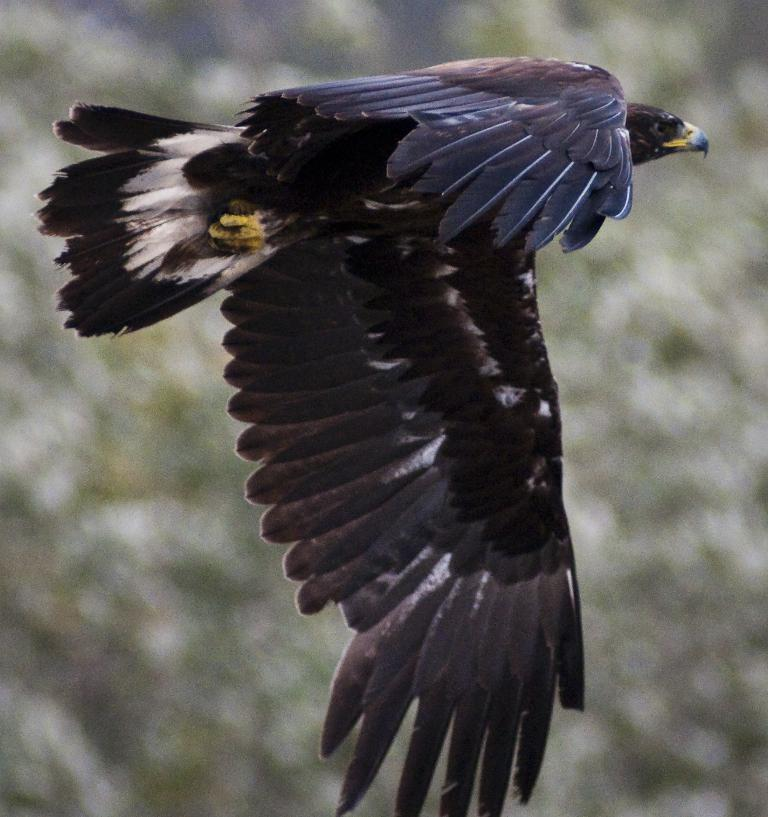What is the main subject of the image? The main subject of the image is a bird flying in the air. Can you describe the background of the image? The background of the image is blurred. What color is the hydrant in the image? There is no hydrant present in the image. What type of baseball equipment can be seen in the image? There is no baseball equipment present in the image. 